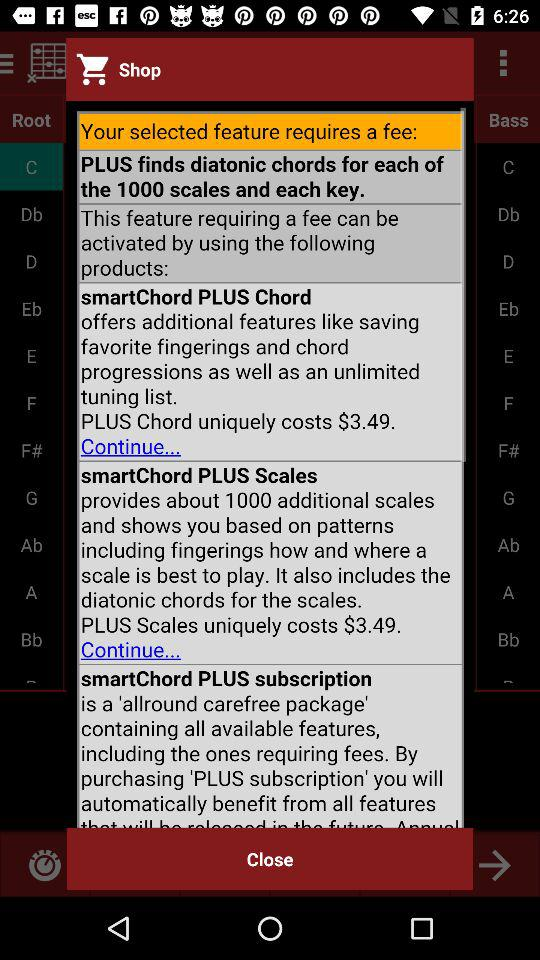How many products are available to activate the feature requiring a fee?
Answer the question using a single word or phrase. 3 